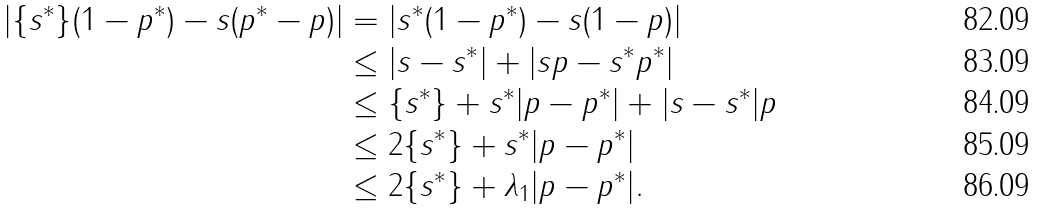<formula> <loc_0><loc_0><loc_500><loc_500>| \{ s ^ { * } \} ( 1 - p ^ { * } ) - s ( p ^ { * } - p ) | & = | s ^ { * } ( 1 - p ^ { * } ) - s ( 1 - p ) | \\ & \leq | s - s ^ { * } | + | s p - s ^ { * } p ^ { * } | \\ & \leq \{ s ^ { * } \} + s ^ { * } | p - p ^ { * } | + | s - s ^ { * } | p \\ & \leq 2 \{ s ^ { * } \} + s ^ { * } | p - p ^ { * } | \\ & \leq 2 \{ s ^ { * } \} + \lambda _ { 1 } | p - p ^ { * } | .</formula> 